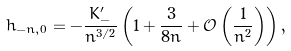<formula> <loc_0><loc_0><loc_500><loc_500>h _ { - n , 0 } = - \frac { K _ { - } ^ { \prime } } { n ^ { 3 / 2 } } \left ( 1 + \frac { 3 } { 8 n } + { \mathcal { O } } \left ( \frac { 1 } { n ^ { 2 } } \right ) \right ) ,</formula> 